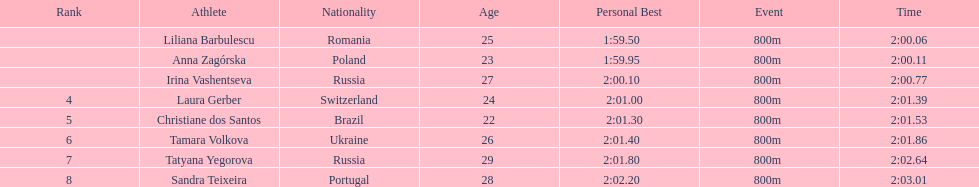Anna zagorska recieved 2nd place, what was her time? 2:00.11. 